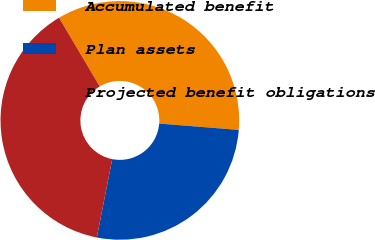Convert chart to OTSL. <chart><loc_0><loc_0><loc_500><loc_500><pie_chart><fcel>Accumulated benefit<fcel>Plan assets<fcel>Projected benefit obligations<nl><fcel>34.78%<fcel>26.82%<fcel>38.4%<nl></chart> 